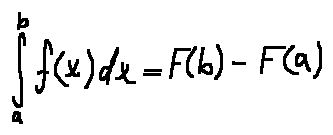Convert formula to latex. <formula><loc_0><loc_0><loc_500><loc_500>\int \lim i t s _ { a } ^ { b } f ( x ) d x = F ( b ) - F ( a )</formula> 